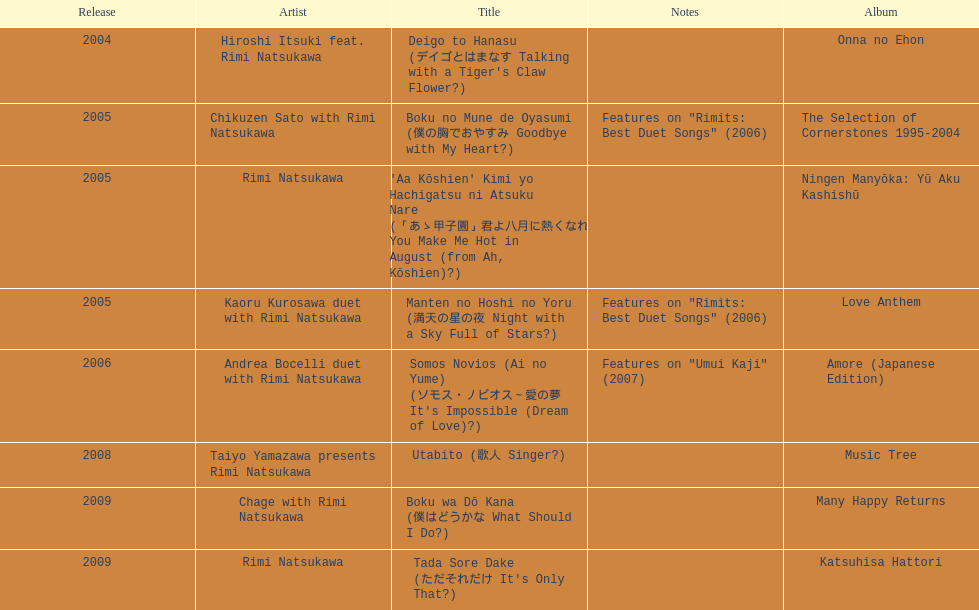What is the count of titles that feature solely one artist? 2. 